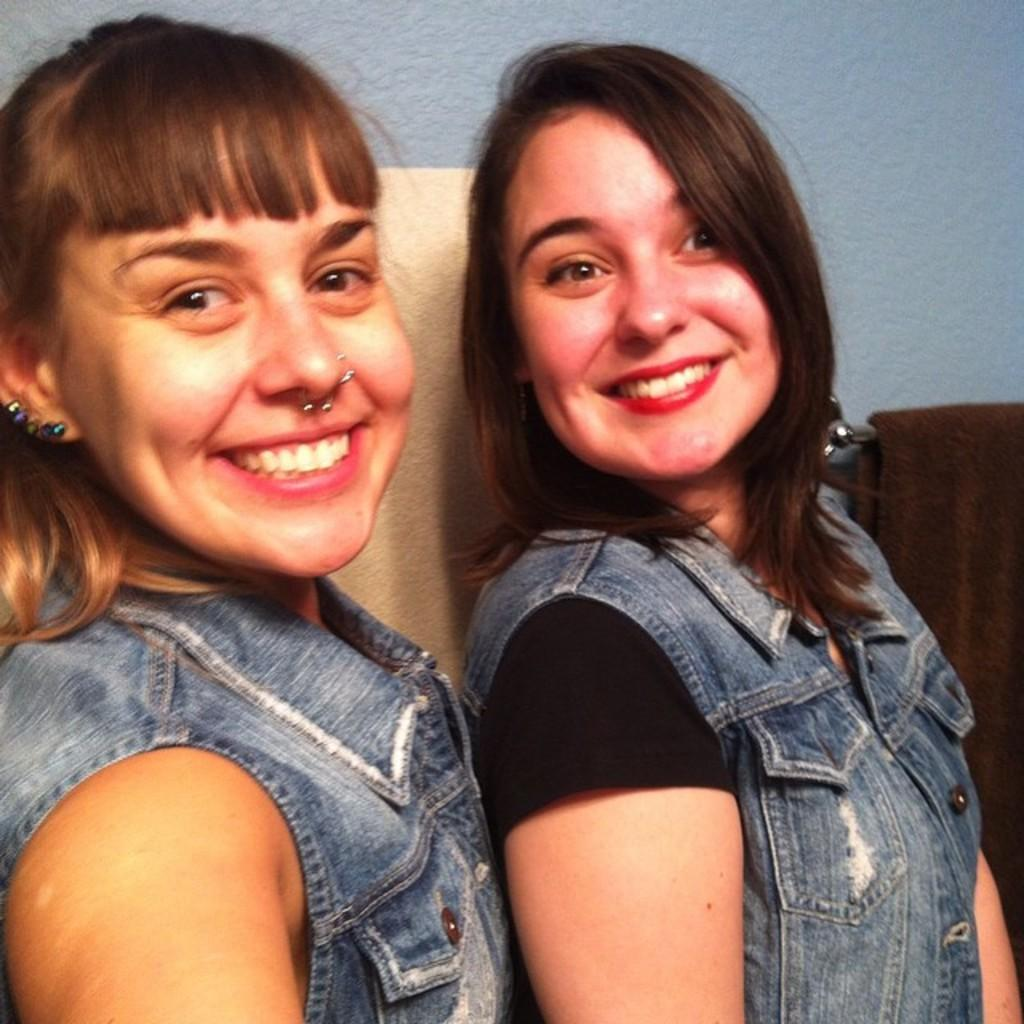How many people are in the image? There are two persons in the image. What is the cloth used for in the image? The cloth is hanging on a metal on the right side of the image, but its purpose is not specified. What is the background of the image? There is a wall in the image. How much money did the persons in the image save for their vacation? There is no information about money or a vacation in the image, so we cannot determine how much money was saved. 